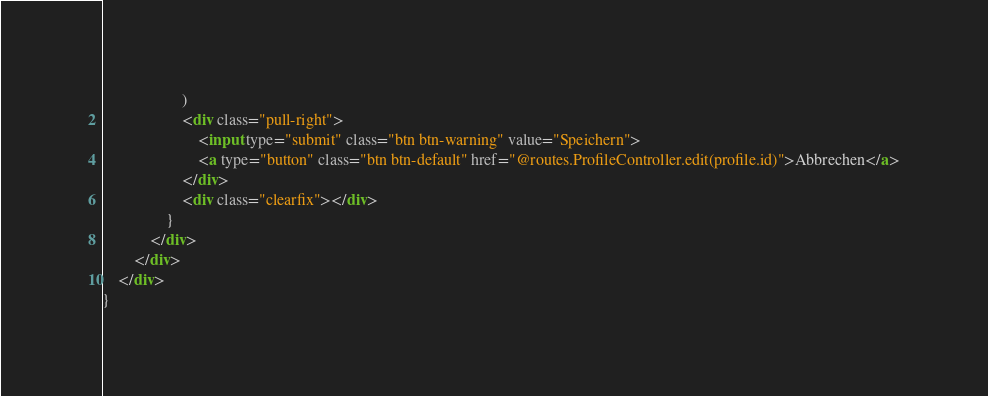Convert code to text. <code><loc_0><loc_0><loc_500><loc_500><_HTML_>                    )
                    <div class="pull-right">
                        <input type="submit" class="btn btn-warning" value="Speichern">
                        <a type="button" class="btn btn-default" href="@routes.ProfileController.edit(profile.id)">Abbrechen</a>
                    </div>
                    <div class="clearfix"></div>
                }
            </div>
        </div>
    </div>
}</code> 